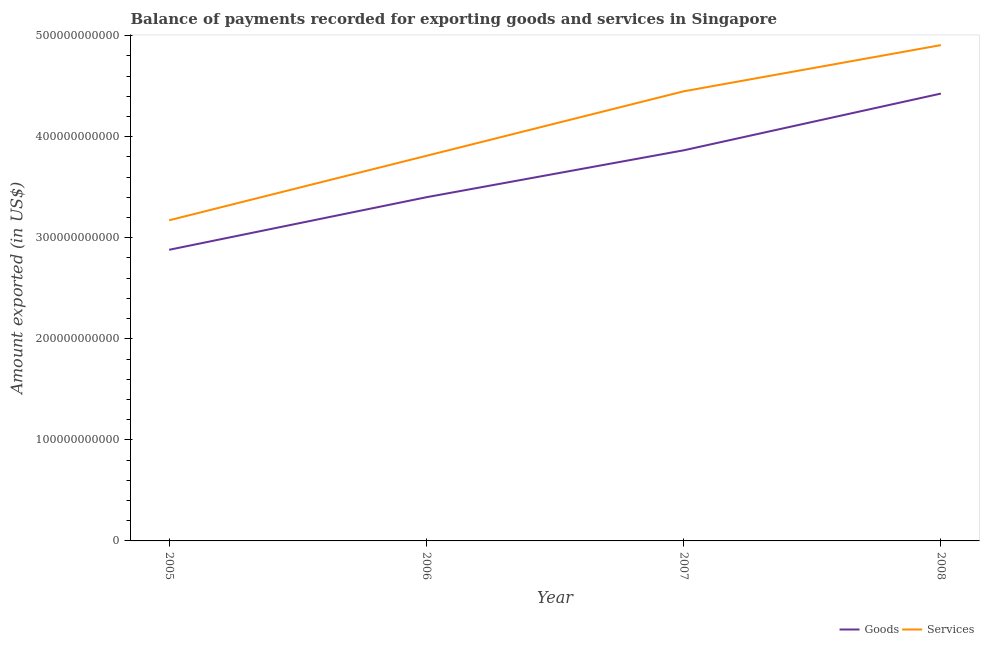Is the number of lines equal to the number of legend labels?
Make the answer very short. Yes. What is the amount of goods exported in 2008?
Provide a succinct answer. 4.43e+11. Across all years, what is the maximum amount of goods exported?
Keep it short and to the point. 4.43e+11. Across all years, what is the minimum amount of services exported?
Make the answer very short. 3.17e+11. In which year was the amount of goods exported maximum?
Offer a very short reply. 2008. In which year was the amount of services exported minimum?
Offer a terse response. 2005. What is the total amount of services exported in the graph?
Your answer should be very brief. 1.63e+12. What is the difference between the amount of goods exported in 2005 and that in 2006?
Your answer should be compact. -5.20e+1. What is the difference between the amount of goods exported in 2007 and the amount of services exported in 2006?
Your response must be concise. 5.44e+09. What is the average amount of services exported per year?
Provide a short and direct response. 4.08e+11. In the year 2007, what is the difference between the amount of goods exported and amount of services exported?
Provide a succinct answer. -5.84e+1. What is the ratio of the amount of services exported in 2006 to that in 2008?
Provide a short and direct response. 0.78. Is the difference between the amount of goods exported in 2007 and 2008 greater than the difference between the amount of services exported in 2007 and 2008?
Offer a very short reply. No. What is the difference between the highest and the second highest amount of services exported?
Ensure brevity in your answer.  4.57e+1. What is the difference between the highest and the lowest amount of goods exported?
Offer a terse response. 1.55e+11. Is the amount of goods exported strictly less than the amount of services exported over the years?
Offer a very short reply. Yes. How many years are there in the graph?
Your answer should be very brief. 4. What is the difference between two consecutive major ticks on the Y-axis?
Provide a succinct answer. 1.00e+11. How are the legend labels stacked?
Offer a very short reply. Horizontal. What is the title of the graph?
Keep it short and to the point. Balance of payments recorded for exporting goods and services in Singapore. Does "Not attending school" appear as one of the legend labels in the graph?
Your answer should be very brief. No. What is the label or title of the X-axis?
Your response must be concise. Year. What is the label or title of the Y-axis?
Keep it short and to the point. Amount exported (in US$). What is the Amount exported (in US$) of Goods in 2005?
Offer a terse response. 2.88e+11. What is the Amount exported (in US$) of Services in 2005?
Provide a succinct answer. 3.17e+11. What is the Amount exported (in US$) in Goods in 2006?
Your answer should be compact. 3.40e+11. What is the Amount exported (in US$) in Services in 2006?
Offer a very short reply. 3.81e+11. What is the Amount exported (in US$) of Goods in 2007?
Offer a terse response. 3.86e+11. What is the Amount exported (in US$) of Services in 2007?
Your answer should be very brief. 4.45e+11. What is the Amount exported (in US$) in Goods in 2008?
Your answer should be compact. 4.43e+11. What is the Amount exported (in US$) of Services in 2008?
Offer a very short reply. 4.91e+11. Across all years, what is the maximum Amount exported (in US$) of Goods?
Your answer should be compact. 4.43e+11. Across all years, what is the maximum Amount exported (in US$) of Services?
Ensure brevity in your answer.  4.91e+11. Across all years, what is the minimum Amount exported (in US$) of Goods?
Provide a succinct answer. 2.88e+11. Across all years, what is the minimum Amount exported (in US$) of Services?
Your response must be concise. 3.17e+11. What is the total Amount exported (in US$) of Goods in the graph?
Make the answer very short. 1.46e+12. What is the total Amount exported (in US$) in Services in the graph?
Your response must be concise. 1.63e+12. What is the difference between the Amount exported (in US$) of Goods in 2005 and that in 2006?
Your answer should be compact. -5.20e+1. What is the difference between the Amount exported (in US$) in Services in 2005 and that in 2006?
Ensure brevity in your answer.  -6.38e+1. What is the difference between the Amount exported (in US$) of Goods in 2005 and that in 2007?
Provide a succinct answer. -9.84e+1. What is the difference between the Amount exported (in US$) of Services in 2005 and that in 2007?
Give a very brief answer. -1.28e+11. What is the difference between the Amount exported (in US$) in Goods in 2005 and that in 2008?
Provide a short and direct response. -1.55e+11. What is the difference between the Amount exported (in US$) of Services in 2005 and that in 2008?
Your answer should be very brief. -1.73e+11. What is the difference between the Amount exported (in US$) in Goods in 2006 and that in 2007?
Keep it short and to the point. -4.64e+1. What is the difference between the Amount exported (in US$) of Services in 2006 and that in 2007?
Keep it short and to the point. -6.38e+1. What is the difference between the Amount exported (in US$) in Goods in 2006 and that in 2008?
Provide a succinct answer. -1.03e+11. What is the difference between the Amount exported (in US$) of Services in 2006 and that in 2008?
Make the answer very short. -1.10e+11. What is the difference between the Amount exported (in US$) of Goods in 2007 and that in 2008?
Offer a very short reply. -5.62e+1. What is the difference between the Amount exported (in US$) in Services in 2007 and that in 2008?
Your response must be concise. -4.57e+1. What is the difference between the Amount exported (in US$) of Goods in 2005 and the Amount exported (in US$) of Services in 2006?
Offer a very short reply. -9.30e+1. What is the difference between the Amount exported (in US$) in Goods in 2005 and the Amount exported (in US$) in Services in 2007?
Ensure brevity in your answer.  -1.57e+11. What is the difference between the Amount exported (in US$) in Goods in 2005 and the Amount exported (in US$) in Services in 2008?
Ensure brevity in your answer.  -2.03e+11. What is the difference between the Amount exported (in US$) of Goods in 2006 and the Amount exported (in US$) of Services in 2007?
Provide a short and direct response. -1.05e+11. What is the difference between the Amount exported (in US$) of Goods in 2006 and the Amount exported (in US$) of Services in 2008?
Provide a succinct answer. -1.51e+11. What is the difference between the Amount exported (in US$) of Goods in 2007 and the Amount exported (in US$) of Services in 2008?
Provide a succinct answer. -1.04e+11. What is the average Amount exported (in US$) in Goods per year?
Provide a succinct answer. 3.64e+11. What is the average Amount exported (in US$) of Services per year?
Provide a succinct answer. 4.08e+11. In the year 2005, what is the difference between the Amount exported (in US$) of Goods and Amount exported (in US$) of Services?
Offer a terse response. -2.92e+1. In the year 2006, what is the difference between the Amount exported (in US$) of Goods and Amount exported (in US$) of Services?
Offer a terse response. -4.10e+1. In the year 2007, what is the difference between the Amount exported (in US$) in Goods and Amount exported (in US$) in Services?
Make the answer very short. -5.84e+1. In the year 2008, what is the difference between the Amount exported (in US$) in Goods and Amount exported (in US$) in Services?
Provide a succinct answer. -4.79e+1. What is the ratio of the Amount exported (in US$) in Goods in 2005 to that in 2006?
Your answer should be very brief. 0.85. What is the ratio of the Amount exported (in US$) in Services in 2005 to that in 2006?
Keep it short and to the point. 0.83. What is the ratio of the Amount exported (in US$) in Goods in 2005 to that in 2007?
Offer a terse response. 0.75. What is the ratio of the Amount exported (in US$) in Services in 2005 to that in 2007?
Keep it short and to the point. 0.71. What is the ratio of the Amount exported (in US$) of Goods in 2005 to that in 2008?
Your answer should be compact. 0.65. What is the ratio of the Amount exported (in US$) of Services in 2005 to that in 2008?
Ensure brevity in your answer.  0.65. What is the ratio of the Amount exported (in US$) of Goods in 2006 to that in 2007?
Make the answer very short. 0.88. What is the ratio of the Amount exported (in US$) in Services in 2006 to that in 2007?
Your response must be concise. 0.86. What is the ratio of the Amount exported (in US$) of Goods in 2006 to that in 2008?
Give a very brief answer. 0.77. What is the ratio of the Amount exported (in US$) in Services in 2006 to that in 2008?
Make the answer very short. 0.78. What is the ratio of the Amount exported (in US$) in Goods in 2007 to that in 2008?
Provide a succinct answer. 0.87. What is the ratio of the Amount exported (in US$) in Services in 2007 to that in 2008?
Provide a short and direct response. 0.91. What is the difference between the highest and the second highest Amount exported (in US$) in Goods?
Ensure brevity in your answer.  5.62e+1. What is the difference between the highest and the second highest Amount exported (in US$) of Services?
Give a very brief answer. 4.57e+1. What is the difference between the highest and the lowest Amount exported (in US$) in Goods?
Keep it short and to the point. 1.55e+11. What is the difference between the highest and the lowest Amount exported (in US$) of Services?
Your response must be concise. 1.73e+11. 